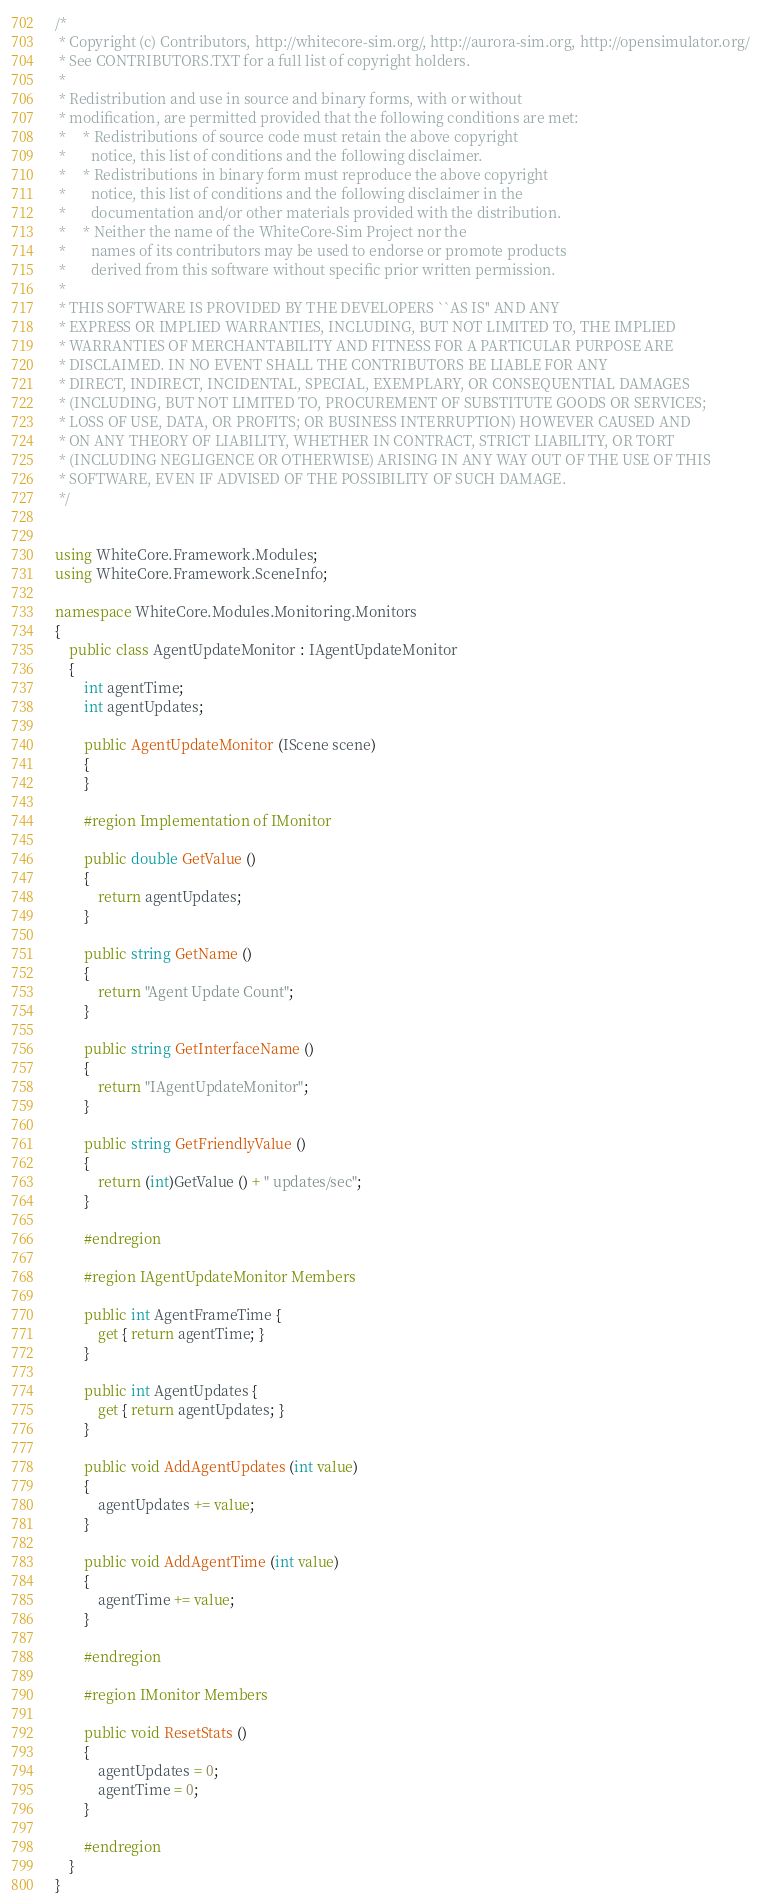Convert code to text. <code><loc_0><loc_0><loc_500><loc_500><_C#_>/*
 * Copyright (c) Contributors, http://whitecore-sim.org/, http://aurora-sim.org, http://opensimulator.org/
 * See CONTRIBUTORS.TXT for a full list of copyright holders.
 *
 * Redistribution and use in source and binary forms, with or without
 * modification, are permitted provided that the following conditions are met:
 *     * Redistributions of source code must retain the above copyright
 *       notice, this list of conditions and the following disclaimer.
 *     * Redistributions in binary form must reproduce the above copyright
 *       notice, this list of conditions and the following disclaimer in the
 *       documentation and/or other materials provided with the distribution.
 *     * Neither the name of the WhiteCore-Sim Project nor the
 *       names of its contributors may be used to endorse or promote products
 *       derived from this software without specific prior written permission.
 *
 * THIS SOFTWARE IS PROVIDED BY THE DEVELOPERS ``AS IS'' AND ANY
 * EXPRESS OR IMPLIED WARRANTIES, INCLUDING, BUT NOT LIMITED TO, THE IMPLIED
 * WARRANTIES OF MERCHANTABILITY AND FITNESS FOR A PARTICULAR PURPOSE ARE
 * DISCLAIMED. IN NO EVENT SHALL THE CONTRIBUTORS BE LIABLE FOR ANY
 * DIRECT, INDIRECT, INCIDENTAL, SPECIAL, EXEMPLARY, OR CONSEQUENTIAL DAMAGES
 * (INCLUDING, BUT NOT LIMITED TO, PROCUREMENT OF SUBSTITUTE GOODS OR SERVICES;
 * LOSS OF USE, DATA, OR PROFITS; OR BUSINESS INTERRUPTION) HOWEVER CAUSED AND
 * ON ANY THEORY OF LIABILITY, WHETHER IN CONTRACT, STRICT LIABILITY, OR TORT
 * (INCLUDING NEGLIGENCE OR OTHERWISE) ARISING IN ANY WAY OUT OF THE USE OF THIS
 * SOFTWARE, EVEN IF ADVISED OF THE POSSIBILITY OF SUCH DAMAGE.
 */


using WhiteCore.Framework.Modules;
using WhiteCore.Framework.SceneInfo;

namespace WhiteCore.Modules.Monitoring.Monitors
{
    public class AgentUpdateMonitor : IAgentUpdateMonitor
    {
        int agentTime;
        int agentUpdates;

        public AgentUpdateMonitor (IScene scene)
        {
        }

        #region Implementation of IMonitor

        public double GetValue ()
        {
            return agentUpdates;
        }

        public string GetName ()
        {
            return "Agent Update Count";
        }

        public string GetInterfaceName ()
        {
            return "IAgentUpdateMonitor";
        }

        public string GetFriendlyValue ()
        {
            return (int)GetValue () + " updates/sec";
        }

        #endregion

        #region IAgentUpdateMonitor Members

        public int AgentFrameTime {
            get { return agentTime; }
        }

        public int AgentUpdates {
            get { return agentUpdates; }
        }

        public void AddAgentUpdates (int value)
        {
            agentUpdates += value;
        }

        public void AddAgentTime (int value)
        {
            agentTime += value;
        }

        #endregion

        #region IMonitor Members

        public void ResetStats ()
        {
            agentUpdates = 0;
            agentTime = 0;
        }

        #endregion
    }
}
</code> 